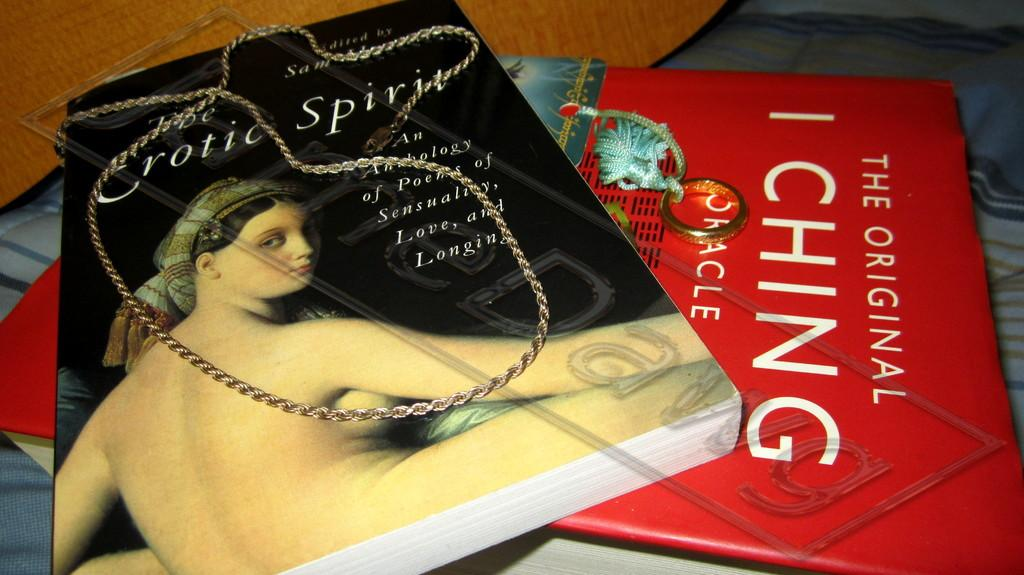<image>
Create a compact narrative representing the image presented. A red book titled "The Original I Ching" sits under another book. 